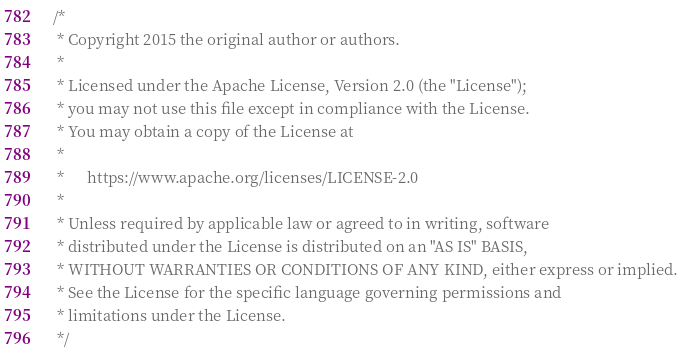Convert code to text. <code><loc_0><loc_0><loc_500><loc_500><_Java_>/*
 * Copyright 2015 the original author or authors.
 *
 * Licensed under the Apache License, Version 2.0 (the "License");
 * you may not use this file except in compliance with the License.
 * You may obtain a copy of the License at
 *
 *      https://www.apache.org/licenses/LICENSE-2.0
 *
 * Unless required by applicable law or agreed to in writing, software
 * distributed under the License is distributed on an "AS IS" BASIS,
 * WITHOUT WARRANTIES OR CONDITIONS OF ANY KIND, either express or implied.
 * See the License for the specific language governing permissions and
 * limitations under the License.
 */
</code> 